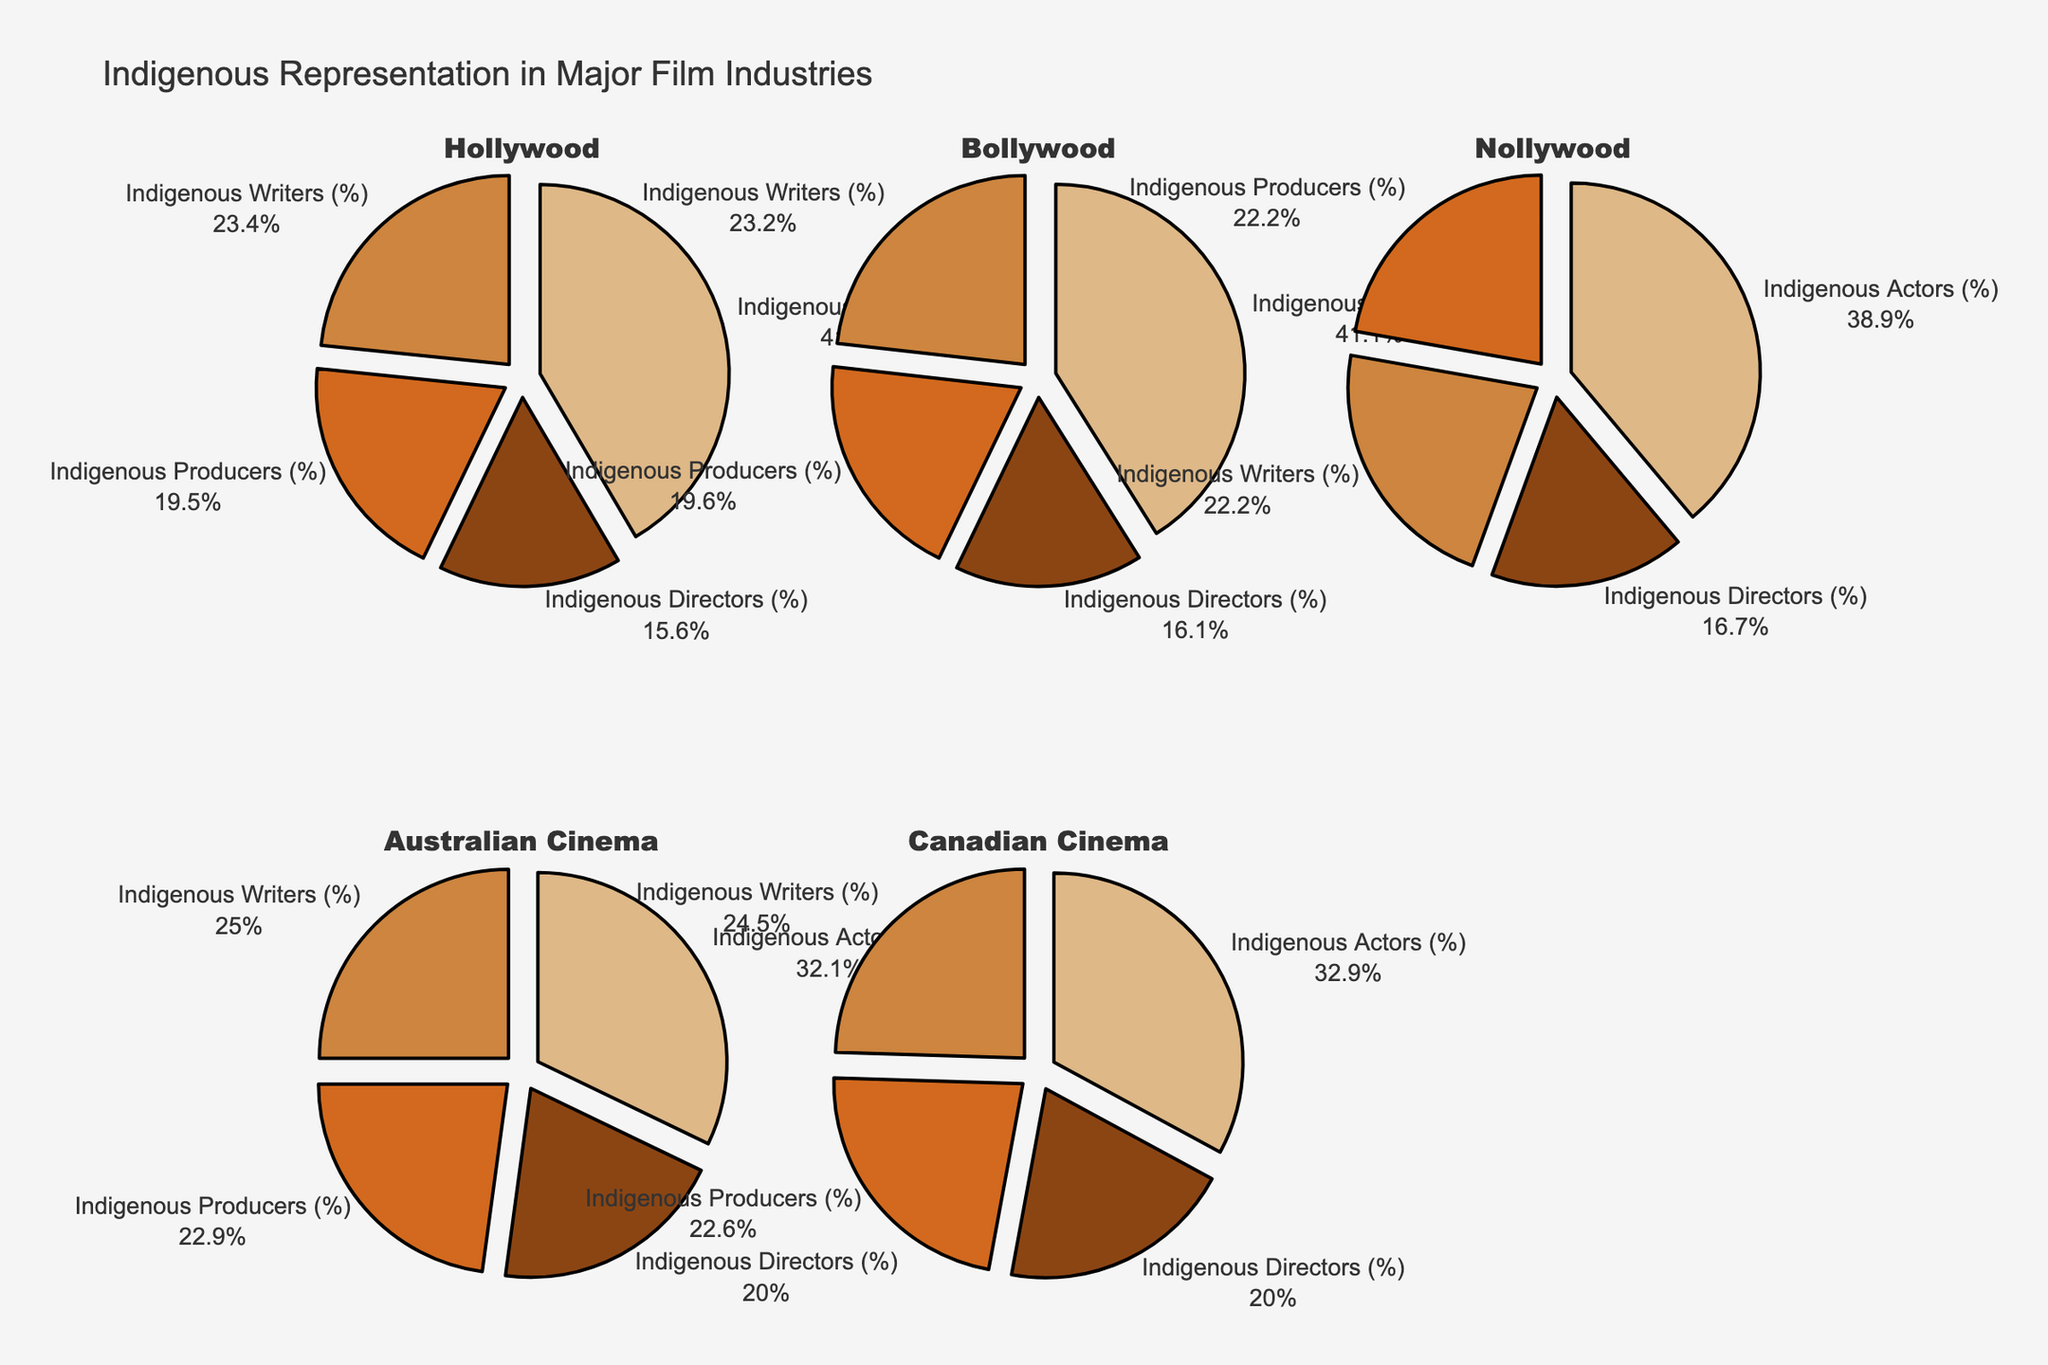What's the highest percentage of Indigenous representation in major film industries? To find the highest percentage, look at the five pie charts and compare the percentages for Indigenous representation. The highest value is in Canadian Cinema with 5.1% for Indigenous Actors.
Answer: 5.1% Which film industry has the smallest percentage of Indigenous representation? Compare the percentages from all the pie charts. The smallest percentage is in Nollywood at 0.3% for Indigenous Directors.
Answer: 0.3% How does the percentage of Indigenous writers in Australian Cinema compare to that in Canadian Cinema? The pie chart for Indigenous Writers shows 3.5% for Australian Cinema and 3.8% for Canadian Cinema. Comparing these, Canadian Cinema has a slightly higher representation.
Answer: Canadian Cinema has a higher percentage What's the total Indigenous representation across all categories in Bollywood? Add up the percentages for each category in Bollywood: 1.8% (Representation) + 0.9% (Directors) + 1.1% (Producers) + 1.3% (Writers) + 2.3% (Actors) = 7.4%.
Answer: 7.4% Which category has the greatest disparity in Indigenous representation between Hollywood and Nollywood? Compare the differences in each category between Hollywood and Nollywood: 
- Representation: 2.5% - 0.5% = 2%
- Directors: 1.2% - 0.3% = 0.9%
- Producers: 1.5% - 0.4% = 1.1%
- Writers: 1.8% - 0.4% = 1.4%
- Actors: 3.2% - 0.7% = 2.5%
The greatest disparity is in Indigenous Actors with a 2.5% difference.
Answer: Indigenous Actors What's the average Indigenous Actors representation across all industries? Sum the percentages for Indigenous Actors in each industry and divide by the number of industries: (3.2% + 2.3% + 0.7% + 4.5% + 5.1%) / 5 = 15.8% / 5 = 3.16%.
Answer: 3.16% Which film industry shows the highest Indigenous representation in producers? Look at Indigenous Producers' pie chart. The highest percentage is in Canadian Cinema with 3.5%.
Answer: Canadian Cinema How does the Indigenous representation in Directors compare between Australian Cinema and Bollywood? The Indigenous Directors pie chart shows 2.8% for Australian Cinema and 0.9% for Bollywood. Australian Cinema has a higher percentage of Indigenous Directors.
Answer: Australian Cinema has a higher percentage What's the difference in Indigenous Writers' representation between the industry with the highest and lowest percentages? Identify the highest and lowest values from the Indigenous Writers' pie chart. The highest is Canadian Cinema (3.8%) and the lowest is Nollywood (0.4%). The difference is 3.8% - 0.4% = 3.4%.
Answer: 3.4% 